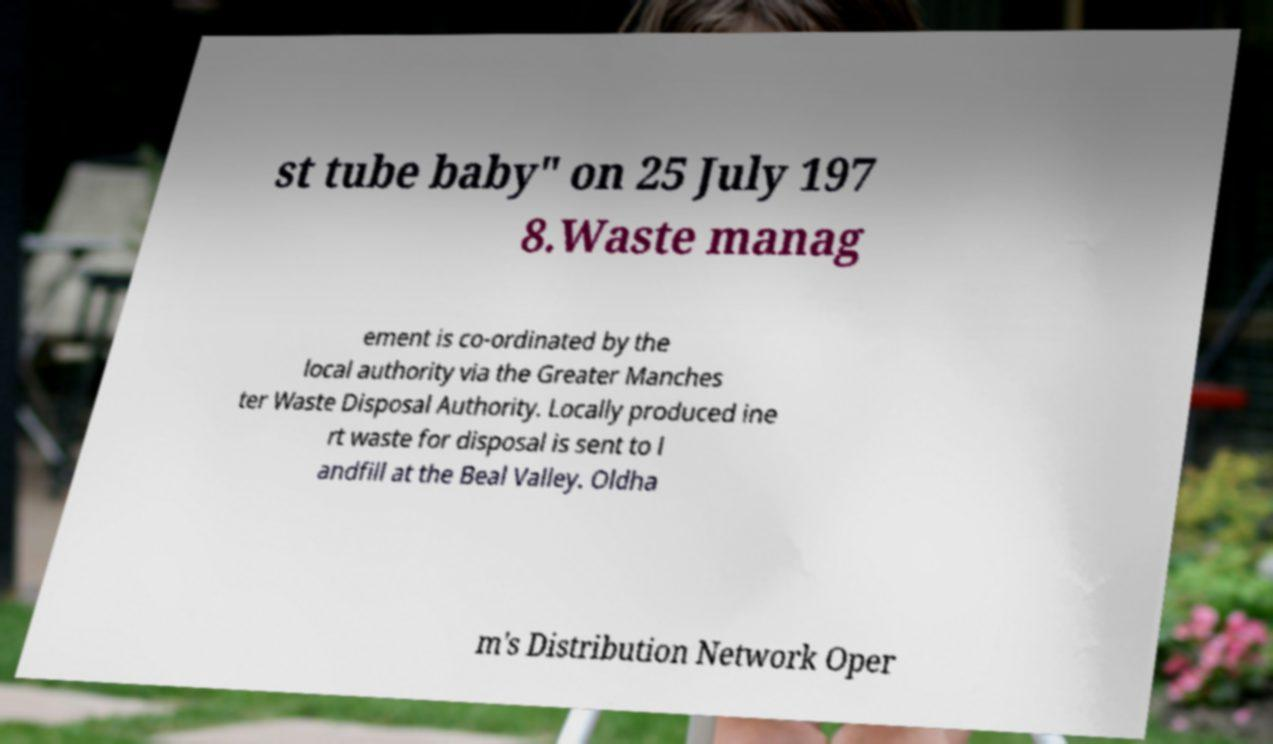I need the written content from this picture converted into text. Can you do that? st tube baby" on 25 July 197 8.Waste manag ement is co-ordinated by the local authority via the Greater Manches ter Waste Disposal Authority. Locally produced ine rt waste for disposal is sent to l andfill at the Beal Valley. Oldha m's Distribution Network Oper 